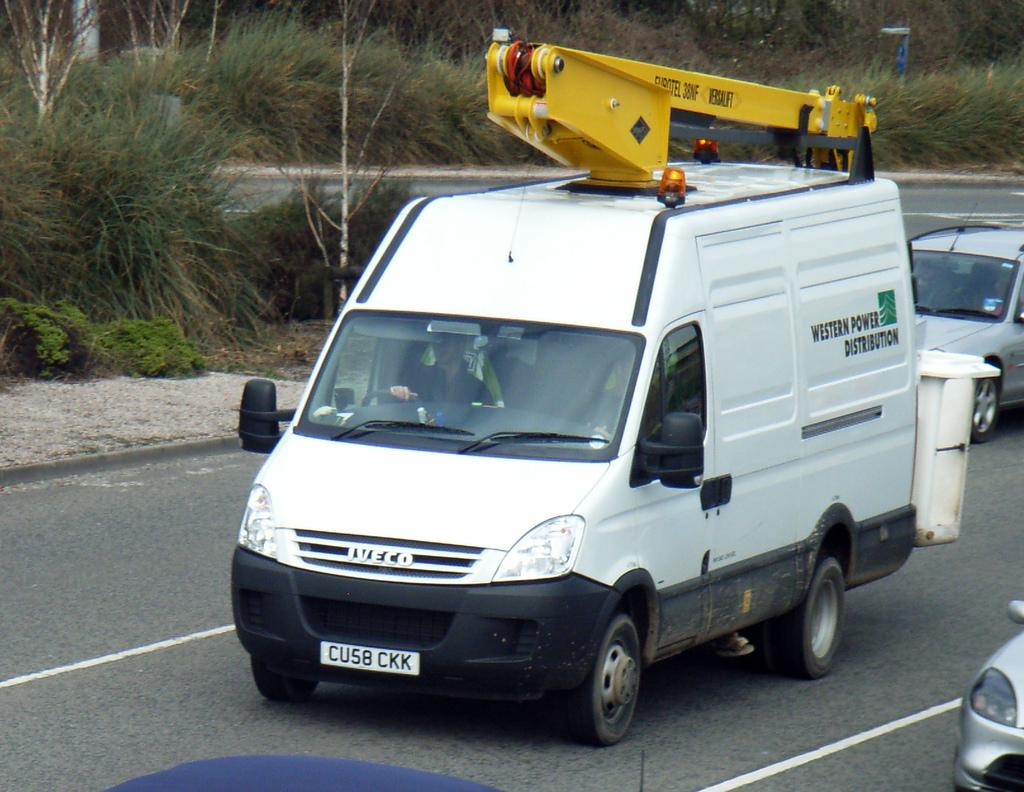<image>
Give a short and clear explanation of the subsequent image. A white van that says western power distribution. 